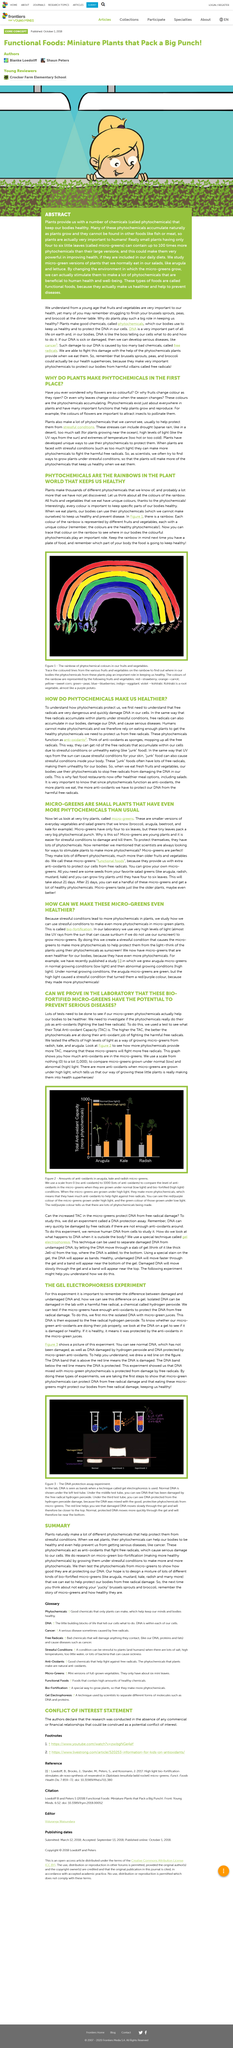Specify some key components in this picture. The presence of anti-oxidants provides protection against damage. Leaves change color during the transition between seasons due to the accumulation of phytochemicals within the plant. Hydrogen peroxide is a chemical that can damage isolated DNA in a laboratory setting. The experiment used a gel as its substance. Fruit change color as they ripen due to the accumulation of phytochemicals. 